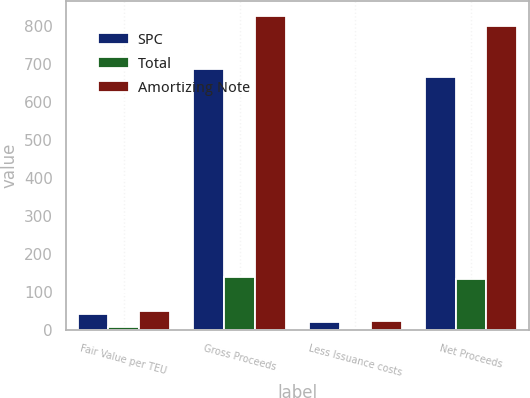<chart> <loc_0><loc_0><loc_500><loc_500><stacked_bar_chart><ecel><fcel>Fair Value per TEU<fcel>Gross Proceeds<fcel>Less Issuance costs<fcel>Net Proceeds<nl><fcel>SPC<fcel>41.5<fcel>685.5<fcel>20.4<fcel>665.1<nl><fcel>Total<fcel>8.5<fcel>139.5<fcel>4.4<fcel>135.1<nl><fcel>Amortizing Note<fcel>50<fcel>825<fcel>24.8<fcel>800.2<nl></chart> 